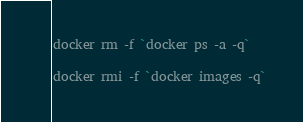<code> <loc_0><loc_0><loc_500><loc_500><_Bash_>
docker rm -f `docker ps -a -q`

docker rmi -f `docker images -q`

</code> 